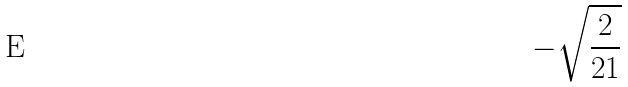Convert formula to latex. <formula><loc_0><loc_0><loc_500><loc_500>- \sqrt { \frac { 2 } { 2 1 } }</formula> 